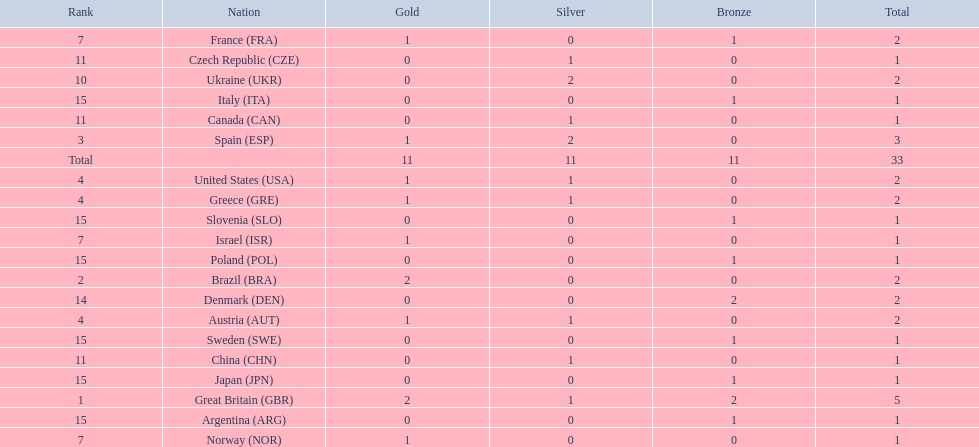What nation was next to great britain in total medal count? Spain. 